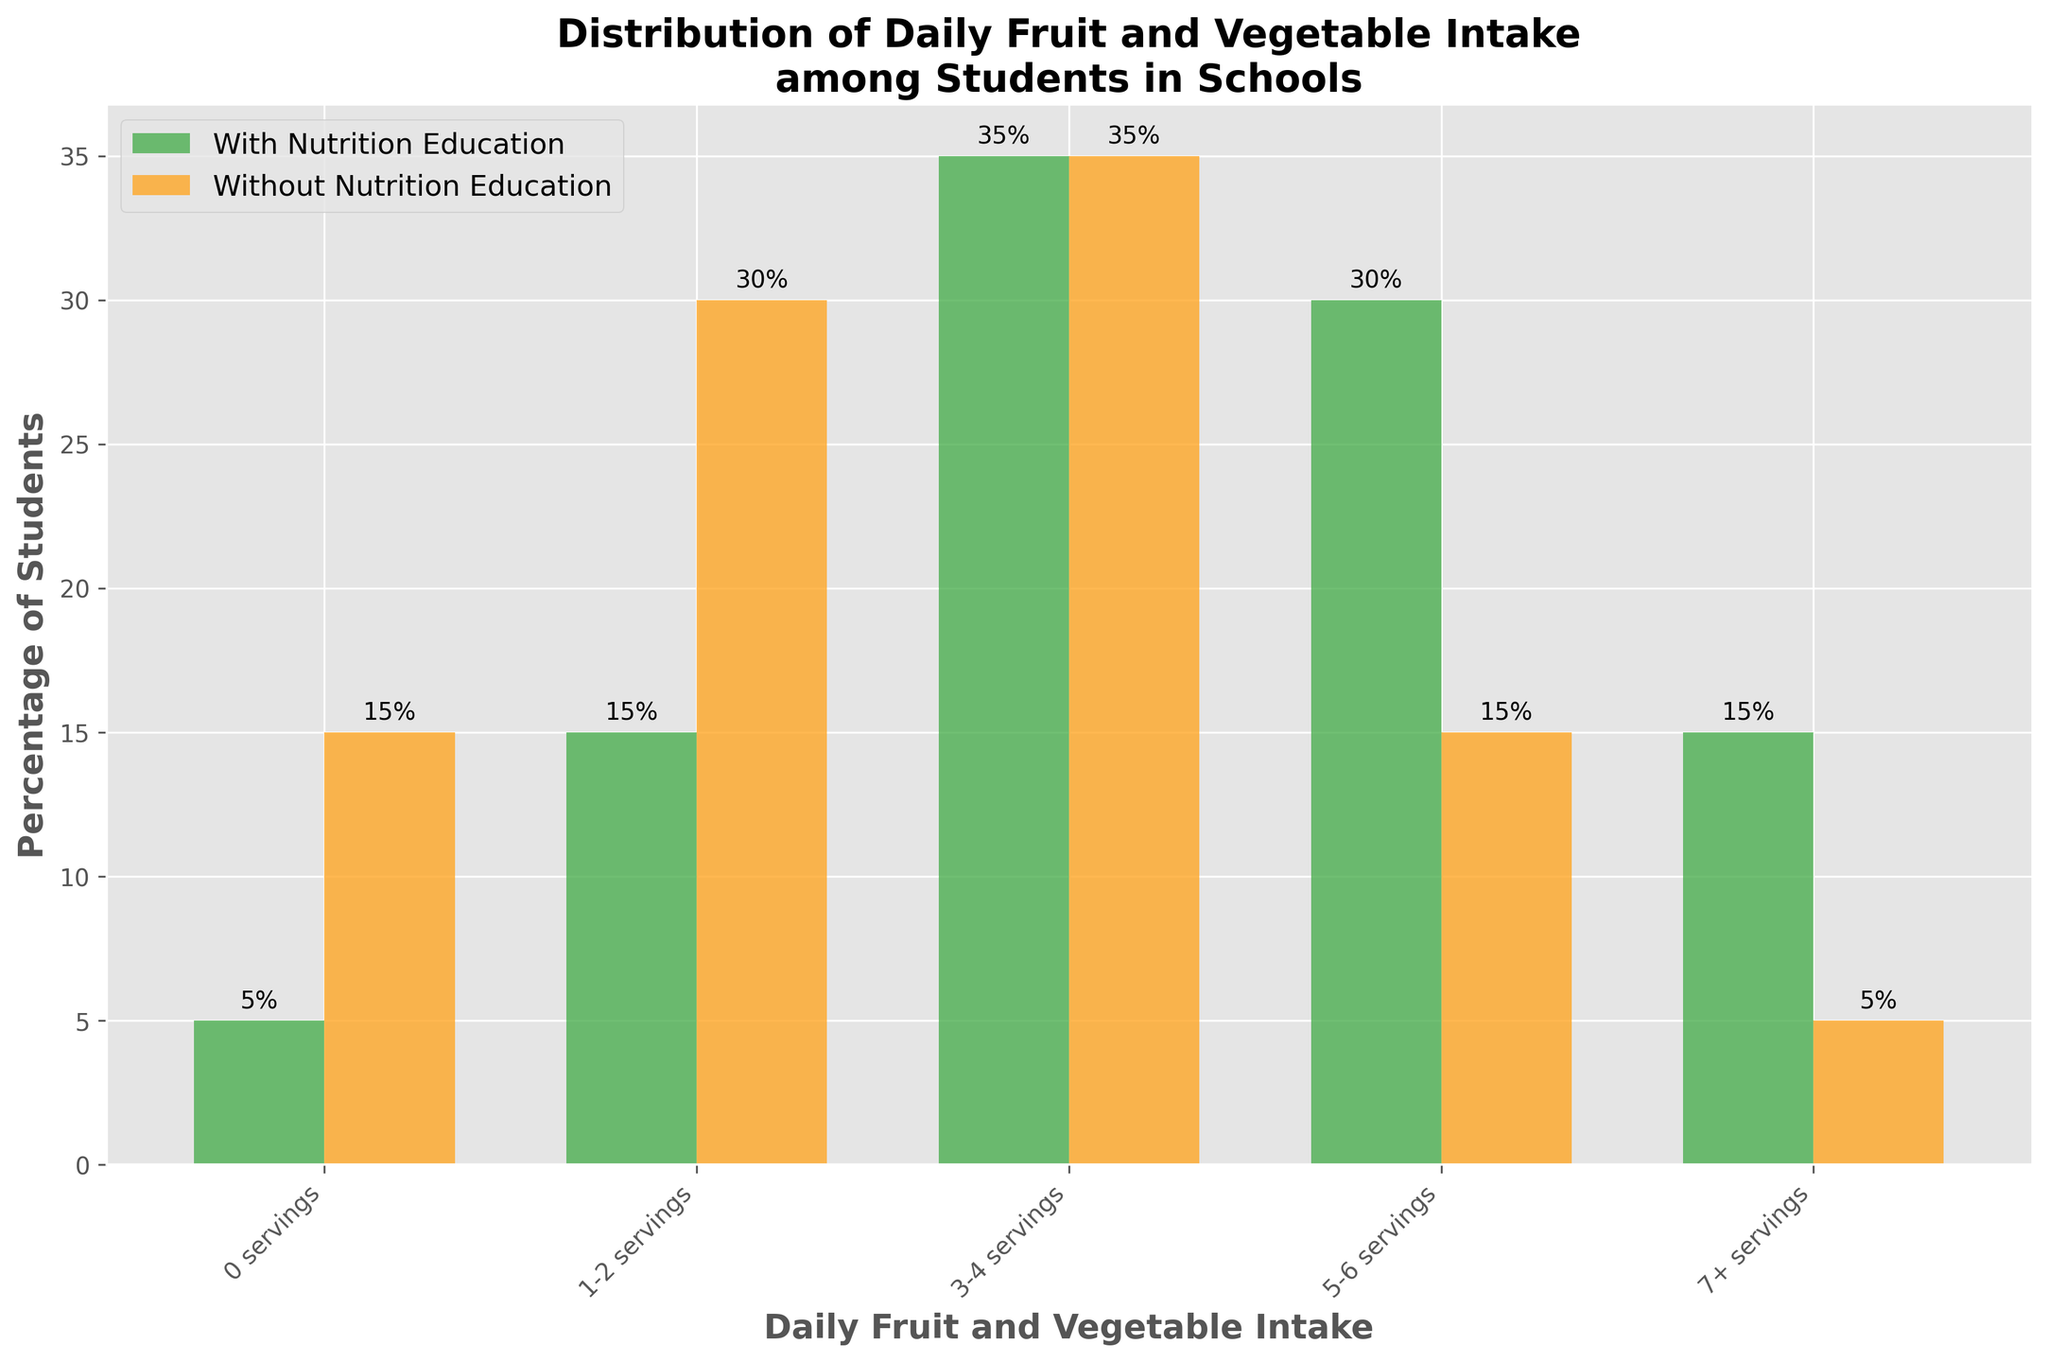What percentage of students in schools with nutrition education consume 5-6 servings of fruits and vegetables daily? The '5-6 servings' bar for schools with nutrition education indicates 30%, as shown on the y-axis next to the bar and the annotation above it.
Answer: 30% Which intake level has the largest difference between schools with and without nutrition education? To find the largest difference, compare the heights or values of each pair of bars. The '0 servings' level shows the largest difference, with 5% in schools with nutrition education and 15% in schools without, resulting in a difference of 10%.
Answer: 0 servings How many more students consume 7+ servings of fruits and vegetables in schools with nutrition education compared to those without it? For '7+ servings,' the bar for schools with nutrition education is 15%, while the bar for schools without is 5%. The difference is 15% - 5% = 10%.
Answer: 10% What is the total percentage of students consuming between 3-6 servings inclusive, in schools with nutrition education? Add the percentages for '3-4 servings' and '5-6 servings' in schools with nutrition education: 35% + 30% = 65%.
Answer: 65% In schools without nutrition education, what is the range of percentages of students consuming 0-2 servings compared to those with 7+ servings? For '0 servings' and '1-2 servings' in no education schools, the values are 15% and 30% respectively, totalling 45%. For '7+ servings,' it is 5%. The range is 45% - 5% = 40%.
Answer: 40% Which intake category has an equal percentage of students in schools with and without nutrition education? For the '3-4 servings' intake category, both types of schools have an equal percentage, 35%.
Answer: 3-4 servings How many more students in schools without nutrition education consume 1-2 servings of fruits and vegetables compared to 7+ servings? For '1-2 servings,' the percentage is 30% whereas for '7+ servings,' it is 5%. The difference is 30% - 5% = 25%.
Answer: 25% What is the average percentage of students consuming 0 and 7+ servings in schools with nutrition education? For 0 servings it is 5%, and for 7+ servings, it is 15%. The average is (5% + 15%) / 2 = 10%.
Answer: 10% 